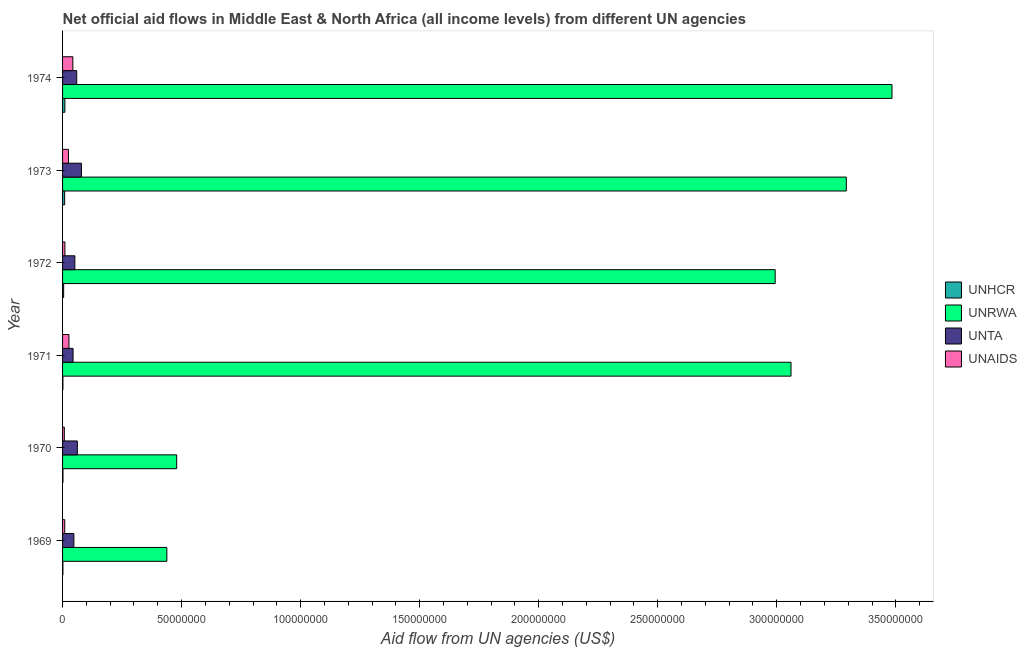Are the number of bars on each tick of the Y-axis equal?
Your response must be concise. Yes. How many bars are there on the 2nd tick from the bottom?
Provide a succinct answer. 4. What is the amount of aid given by unrwa in 1969?
Give a very brief answer. 4.38e+07. Across all years, what is the maximum amount of aid given by unhcr?
Give a very brief answer. 9.70e+05. Across all years, what is the minimum amount of aid given by unaids?
Offer a terse response. 7.40e+05. In which year was the amount of aid given by unrwa maximum?
Make the answer very short. 1974. What is the total amount of aid given by unaids in the graph?
Your answer should be very brief. 1.21e+07. What is the difference between the amount of aid given by unrwa in 1973 and the amount of aid given by unhcr in 1971?
Provide a succinct answer. 3.29e+08. What is the average amount of aid given by unrwa per year?
Offer a very short reply. 2.29e+08. In the year 1969, what is the difference between the amount of aid given by unaids and amount of aid given by unhcr?
Give a very brief answer. 7.70e+05. In how many years, is the amount of aid given by unrwa greater than 10000000 US$?
Make the answer very short. 6. What is the ratio of the amount of aid given by unta in 1969 to that in 1972?
Make the answer very short. 0.92. Is the amount of aid given by unrwa in 1969 less than that in 1971?
Your response must be concise. Yes. What is the difference between the highest and the second highest amount of aid given by unrwa?
Ensure brevity in your answer.  1.92e+07. What is the difference between the highest and the lowest amount of aid given by unhcr?
Your response must be concise. 8.30e+05. In how many years, is the amount of aid given by unrwa greater than the average amount of aid given by unrwa taken over all years?
Ensure brevity in your answer.  4. What does the 3rd bar from the top in 1974 represents?
Provide a succinct answer. UNRWA. What does the 1st bar from the bottom in 1969 represents?
Keep it short and to the point. UNHCR. How many bars are there?
Your answer should be compact. 24. How many years are there in the graph?
Give a very brief answer. 6. Are the values on the major ticks of X-axis written in scientific E-notation?
Ensure brevity in your answer.  No. Does the graph contain grids?
Your answer should be very brief. No. Where does the legend appear in the graph?
Give a very brief answer. Center right. What is the title of the graph?
Give a very brief answer. Net official aid flows in Middle East & North Africa (all income levels) from different UN agencies. What is the label or title of the X-axis?
Your response must be concise. Aid flow from UN agencies (US$). What is the label or title of the Y-axis?
Give a very brief answer. Year. What is the Aid flow from UN agencies (US$) of UNHCR in 1969?
Offer a terse response. 1.40e+05. What is the Aid flow from UN agencies (US$) in UNRWA in 1969?
Your answer should be very brief. 4.38e+07. What is the Aid flow from UN agencies (US$) in UNTA in 1969?
Offer a terse response. 4.75e+06. What is the Aid flow from UN agencies (US$) in UNAIDS in 1969?
Provide a succinct answer. 9.10e+05. What is the Aid flow from UN agencies (US$) in UNHCR in 1970?
Make the answer very short. 1.70e+05. What is the Aid flow from UN agencies (US$) in UNRWA in 1970?
Make the answer very short. 4.79e+07. What is the Aid flow from UN agencies (US$) in UNTA in 1970?
Keep it short and to the point. 6.21e+06. What is the Aid flow from UN agencies (US$) of UNAIDS in 1970?
Your response must be concise. 7.40e+05. What is the Aid flow from UN agencies (US$) of UNHCR in 1971?
Your response must be concise. 1.40e+05. What is the Aid flow from UN agencies (US$) in UNRWA in 1971?
Keep it short and to the point. 3.06e+08. What is the Aid flow from UN agencies (US$) of UNTA in 1971?
Your answer should be compact. 4.41e+06. What is the Aid flow from UN agencies (US$) in UNAIDS in 1971?
Make the answer very short. 2.68e+06. What is the Aid flow from UN agencies (US$) of UNHCR in 1972?
Give a very brief answer. 4.60e+05. What is the Aid flow from UN agencies (US$) in UNRWA in 1972?
Your answer should be very brief. 2.99e+08. What is the Aid flow from UN agencies (US$) in UNTA in 1972?
Your response must be concise. 5.16e+06. What is the Aid flow from UN agencies (US$) of UNAIDS in 1972?
Keep it short and to the point. 9.80e+05. What is the Aid flow from UN agencies (US$) of UNHCR in 1973?
Your answer should be very brief. 8.80e+05. What is the Aid flow from UN agencies (US$) of UNRWA in 1973?
Offer a terse response. 3.29e+08. What is the Aid flow from UN agencies (US$) in UNTA in 1973?
Provide a short and direct response. 7.93e+06. What is the Aid flow from UN agencies (US$) of UNAIDS in 1973?
Your response must be concise. 2.47e+06. What is the Aid flow from UN agencies (US$) in UNHCR in 1974?
Give a very brief answer. 9.70e+05. What is the Aid flow from UN agencies (US$) of UNRWA in 1974?
Offer a terse response. 3.48e+08. What is the Aid flow from UN agencies (US$) of UNTA in 1974?
Your response must be concise. 5.94e+06. What is the Aid flow from UN agencies (US$) in UNAIDS in 1974?
Give a very brief answer. 4.32e+06. Across all years, what is the maximum Aid flow from UN agencies (US$) of UNHCR?
Give a very brief answer. 9.70e+05. Across all years, what is the maximum Aid flow from UN agencies (US$) of UNRWA?
Provide a succinct answer. 3.48e+08. Across all years, what is the maximum Aid flow from UN agencies (US$) in UNTA?
Your answer should be compact. 7.93e+06. Across all years, what is the maximum Aid flow from UN agencies (US$) in UNAIDS?
Make the answer very short. 4.32e+06. Across all years, what is the minimum Aid flow from UN agencies (US$) of UNHCR?
Provide a short and direct response. 1.40e+05. Across all years, what is the minimum Aid flow from UN agencies (US$) of UNRWA?
Provide a short and direct response. 4.38e+07. Across all years, what is the minimum Aid flow from UN agencies (US$) of UNTA?
Keep it short and to the point. 4.41e+06. Across all years, what is the minimum Aid flow from UN agencies (US$) in UNAIDS?
Provide a short and direct response. 7.40e+05. What is the total Aid flow from UN agencies (US$) of UNHCR in the graph?
Provide a short and direct response. 2.76e+06. What is the total Aid flow from UN agencies (US$) in UNRWA in the graph?
Ensure brevity in your answer.  1.37e+09. What is the total Aid flow from UN agencies (US$) of UNTA in the graph?
Your response must be concise. 3.44e+07. What is the total Aid flow from UN agencies (US$) of UNAIDS in the graph?
Make the answer very short. 1.21e+07. What is the difference between the Aid flow from UN agencies (US$) in UNRWA in 1969 and that in 1970?
Offer a terse response. -4.13e+06. What is the difference between the Aid flow from UN agencies (US$) in UNTA in 1969 and that in 1970?
Your response must be concise. -1.46e+06. What is the difference between the Aid flow from UN agencies (US$) in UNAIDS in 1969 and that in 1970?
Provide a succinct answer. 1.70e+05. What is the difference between the Aid flow from UN agencies (US$) of UNRWA in 1969 and that in 1971?
Provide a short and direct response. -2.62e+08. What is the difference between the Aid flow from UN agencies (US$) in UNTA in 1969 and that in 1971?
Give a very brief answer. 3.40e+05. What is the difference between the Aid flow from UN agencies (US$) in UNAIDS in 1969 and that in 1971?
Ensure brevity in your answer.  -1.77e+06. What is the difference between the Aid flow from UN agencies (US$) in UNHCR in 1969 and that in 1972?
Ensure brevity in your answer.  -3.20e+05. What is the difference between the Aid flow from UN agencies (US$) of UNRWA in 1969 and that in 1972?
Ensure brevity in your answer.  -2.56e+08. What is the difference between the Aid flow from UN agencies (US$) in UNTA in 1969 and that in 1972?
Provide a succinct answer. -4.10e+05. What is the difference between the Aid flow from UN agencies (US$) of UNAIDS in 1969 and that in 1972?
Your answer should be compact. -7.00e+04. What is the difference between the Aid flow from UN agencies (US$) in UNHCR in 1969 and that in 1973?
Provide a succinct answer. -7.40e+05. What is the difference between the Aid flow from UN agencies (US$) in UNRWA in 1969 and that in 1973?
Make the answer very short. -2.85e+08. What is the difference between the Aid flow from UN agencies (US$) of UNTA in 1969 and that in 1973?
Your response must be concise. -3.18e+06. What is the difference between the Aid flow from UN agencies (US$) in UNAIDS in 1969 and that in 1973?
Your answer should be very brief. -1.56e+06. What is the difference between the Aid flow from UN agencies (US$) of UNHCR in 1969 and that in 1974?
Offer a very short reply. -8.30e+05. What is the difference between the Aid flow from UN agencies (US$) of UNRWA in 1969 and that in 1974?
Your answer should be compact. -3.05e+08. What is the difference between the Aid flow from UN agencies (US$) in UNTA in 1969 and that in 1974?
Offer a terse response. -1.19e+06. What is the difference between the Aid flow from UN agencies (US$) in UNAIDS in 1969 and that in 1974?
Ensure brevity in your answer.  -3.41e+06. What is the difference between the Aid flow from UN agencies (US$) in UNRWA in 1970 and that in 1971?
Offer a very short reply. -2.58e+08. What is the difference between the Aid flow from UN agencies (US$) in UNTA in 1970 and that in 1971?
Ensure brevity in your answer.  1.80e+06. What is the difference between the Aid flow from UN agencies (US$) of UNAIDS in 1970 and that in 1971?
Give a very brief answer. -1.94e+06. What is the difference between the Aid flow from UN agencies (US$) of UNRWA in 1970 and that in 1972?
Your response must be concise. -2.51e+08. What is the difference between the Aid flow from UN agencies (US$) of UNTA in 1970 and that in 1972?
Ensure brevity in your answer.  1.05e+06. What is the difference between the Aid flow from UN agencies (US$) of UNAIDS in 1970 and that in 1972?
Keep it short and to the point. -2.40e+05. What is the difference between the Aid flow from UN agencies (US$) of UNHCR in 1970 and that in 1973?
Keep it short and to the point. -7.10e+05. What is the difference between the Aid flow from UN agencies (US$) in UNRWA in 1970 and that in 1973?
Your answer should be very brief. -2.81e+08. What is the difference between the Aid flow from UN agencies (US$) of UNTA in 1970 and that in 1973?
Offer a very short reply. -1.72e+06. What is the difference between the Aid flow from UN agencies (US$) in UNAIDS in 1970 and that in 1973?
Ensure brevity in your answer.  -1.73e+06. What is the difference between the Aid flow from UN agencies (US$) in UNHCR in 1970 and that in 1974?
Keep it short and to the point. -8.00e+05. What is the difference between the Aid flow from UN agencies (US$) in UNRWA in 1970 and that in 1974?
Give a very brief answer. -3.00e+08. What is the difference between the Aid flow from UN agencies (US$) of UNAIDS in 1970 and that in 1974?
Provide a short and direct response. -3.58e+06. What is the difference between the Aid flow from UN agencies (US$) in UNHCR in 1971 and that in 1972?
Provide a succinct answer. -3.20e+05. What is the difference between the Aid flow from UN agencies (US$) in UNRWA in 1971 and that in 1972?
Ensure brevity in your answer.  6.65e+06. What is the difference between the Aid flow from UN agencies (US$) of UNTA in 1971 and that in 1972?
Your response must be concise. -7.50e+05. What is the difference between the Aid flow from UN agencies (US$) in UNAIDS in 1971 and that in 1972?
Offer a terse response. 1.70e+06. What is the difference between the Aid flow from UN agencies (US$) in UNHCR in 1971 and that in 1973?
Your response must be concise. -7.40e+05. What is the difference between the Aid flow from UN agencies (US$) in UNRWA in 1971 and that in 1973?
Your answer should be compact. -2.32e+07. What is the difference between the Aid flow from UN agencies (US$) in UNTA in 1971 and that in 1973?
Your answer should be compact. -3.52e+06. What is the difference between the Aid flow from UN agencies (US$) in UNHCR in 1971 and that in 1974?
Your answer should be compact. -8.30e+05. What is the difference between the Aid flow from UN agencies (US$) in UNRWA in 1971 and that in 1974?
Your response must be concise. -4.24e+07. What is the difference between the Aid flow from UN agencies (US$) of UNTA in 1971 and that in 1974?
Make the answer very short. -1.53e+06. What is the difference between the Aid flow from UN agencies (US$) in UNAIDS in 1971 and that in 1974?
Provide a short and direct response. -1.64e+06. What is the difference between the Aid flow from UN agencies (US$) in UNHCR in 1972 and that in 1973?
Offer a terse response. -4.20e+05. What is the difference between the Aid flow from UN agencies (US$) of UNRWA in 1972 and that in 1973?
Provide a succinct answer. -2.99e+07. What is the difference between the Aid flow from UN agencies (US$) in UNTA in 1972 and that in 1973?
Give a very brief answer. -2.77e+06. What is the difference between the Aid flow from UN agencies (US$) of UNAIDS in 1972 and that in 1973?
Offer a very short reply. -1.49e+06. What is the difference between the Aid flow from UN agencies (US$) in UNHCR in 1972 and that in 1974?
Give a very brief answer. -5.10e+05. What is the difference between the Aid flow from UN agencies (US$) in UNRWA in 1972 and that in 1974?
Make the answer very short. -4.91e+07. What is the difference between the Aid flow from UN agencies (US$) in UNTA in 1972 and that in 1974?
Offer a very short reply. -7.80e+05. What is the difference between the Aid flow from UN agencies (US$) in UNAIDS in 1972 and that in 1974?
Offer a very short reply. -3.34e+06. What is the difference between the Aid flow from UN agencies (US$) in UNRWA in 1973 and that in 1974?
Provide a succinct answer. -1.92e+07. What is the difference between the Aid flow from UN agencies (US$) of UNTA in 1973 and that in 1974?
Provide a succinct answer. 1.99e+06. What is the difference between the Aid flow from UN agencies (US$) of UNAIDS in 1973 and that in 1974?
Ensure brevity in your answer.  -1.85e+06. What is the difference between the Aid flow from UN agencies (US$) in UNHCR in 1969 and the Aid flow from UN agencies (US$) in UNRWA in 1970?
Your answer should be compact. -4.78e+07. What is the difference between the Aid flow from UN agencies (US$) of UNHCR in 1969 and the Aid flow from UN agencies (US$) of UNTA in 1970?
Your response must be concise. -6.07e+06. What is the difference between the Aid flow from UN agencies (US$) of UNHCR in 1969 and the Aid flow from UN agencies (US$) of UNAIDS in 1970?
Your response must be concise. -6.00e+05. What is the difference between the Aid flow from UN agencies (US$) of UNRWA in 1969 and the Aid flow from UN agencies (US$) of UNTA in 1970?
Your response must be concise. 3.76e+07. What is the difference between the Aid flow from UN agencies (US$) in UNRWA in 1969 and the Aid flow from UN agencies (US$) in UNAIDS in 1970?
Your answer should be very brief. 4.31e+07. What is the difference between the Aid flow from UN agencies (US$) of UNTA in 1969 and the Aid flow from UN agencies (US$) of UNAIDS in 1970?
Ensure brevity in your answer.  4.01e+06. What is the difference between the Aid flow from UN agencies (US$) of UNHCR in 1969 and the Aid flow from UN agencies (US$) of UNRWA in 1971?
Provide a short and direct response. -3.06e+08. What is the difference between the Aid flow from UN agencies (US$) in UNHCR in 1969 and the Aid flow from UN agencies (US$) in UNTA in 1971?
Offer a very short reply. -4.27e+06. What is the difference between the Aid flow from UN agencies (US$) in UNHCR in 1969 and the Aid flow from UN agencies (US$) in UNAIDS in 1971?
Offer a very short reply. -2.54e+06. What is the difference between the Aid flow from UN agencies (US$) in UNRWA in 1969 and the Aid flow from UN agencies (US$) in UNTA in 1971?
Ensure brevity in your answer.  3.94e+07. What is the difference between the Aid flow from UN agencies (US$) in UNRWA in 1969 and the Aid flow from UN agencies (US$) in UNAIDS in 1971?
Your response must be concise. 4.11e+07. What is the difference between the Aid flow from UN agencies (US$) in UNTA in 1969 and the Aid flow from UN agencies (US$) in UNAIDS in 1971?
Your response must be concise. 2.07e+06. What is the difference between the Aid flow from UN agencies (US$) in UNHCR in 1969 and the Aid flow from UN agencies (US$) in UNRWA in 1972?
Your answer should be very brief. -2.99e+08. What is the difference between the Aid flow from UN agencies (US$) in UNHCR in 1969 and the Aid flow from UN agencies (US$) in UNTA in 1972?
Keep it short and to the point. -5.02e+06. What is the difference between the Aid flow from UN agencies (US$) in UNHCR in 1969 and the Aid flow from UN agencies (US$) in UNAIDS in 1972?
Keep it short and to the point. -8.40e+05. What is the difference between the Aid flow from UN agencies (US$) of UNRWA in 1969 and the Aid flow from UN agencies (US$) of UNTA in 1972?
Provide a short and direct response. 3.86e+07. What is the difference between the Aid flow from UN agencies (US$) in UNRWA in 1969 and the Aid flow from UN agencies (US$) in UNAIDS in 1972?
Ensure brevity in your answer.  4.28e+07. What is the difference between the Aid flow from UN agencies (US$) of UNTA in 1969 and the Aid flow from UN agencies (US$) of UNAIDS in 1972?
Make the answer very short. 3.77e+06. What is the difference between the Aid flow from UN agencies (US$) in UNHCR in 1969 and the Aid flow from UN agencies (US$) in UNRWA in 1973?
Your response must be concise. -3.29e+08. What is the difference between the Aid flow from UN agencies (US$) in UNHCR in 1969 and the Aid flow from UN agencies (US$) in UNTA in 1973?
Make the answer very short. -7.79e+06. What is the difference between the Aid flow from UN agencies (US$) in UNHCR in 1969 and the Aid flow from UN agencies (US$) in UNAIDS in 1973?
Ensure brevity in your answer.  -2.33e+06. What is the difference between the Aid flow from UN agencies (US$) of UNRWA in 1969 and the Aid flow from UN agencies (US$) of UNTA in 1973?
Your response must be concise. 3.59e+07. What is the difference between the Aid flow from UN agencies (US$) of UNRWA in 1969 and the Aid flow from UN agencies (US$) of UNAIDS in 1973?
Make the answer very short. 4.13e+07. What is the difference between the Aid flow from UN agencies (US$) in UNTA in 1969 and the Aid flow from UN agencies (US$) in UNAIDS in 1973?
Ensure brevity in your answer.  2.28e+06. What is the difference between the Aid flow from UN agencies (US$) of UNHCR in 1969 and the Aid flow from UN agencies (US$) of UNRWA in 1974?
Give a very brief answer. -3.48e+08. What is the difference between the Aid flow from UN agencies (US$) of UNHCR in 1969 and the Aid flow from UN agencies (US$) of UNTA in 1974?
Ensure brevity in your answer.  -5.80e+06. What is the difference between the Aid flow from UN agencies (US$) of UNHCR in 1969 and the Aid flow from UN agencies (US$) of UNAIDS in 1974?
Offer a terse response. -4.18e+06. What is the difference between the Aid flow from UN agencies (US$) of UNRWA in 1969 and the Aid flow from UN agencies (US$) of UNTA in 1974?
Ensure brevity in your answer.  3.79e+07. What is the difference between the Aid flow from UN agencies (US$) of UNRWA in 1969 and the Aid flow from UN agencies (US$) of UNAIDS in 1974?
Ensure brevity in your answer.  3.95e+07. What is the difference between the Aid flow from UN agencies (US$) of UNHCR in 1970 and the Aid flow from UN agencies (US$) of UNRWA in 1971?
Ensure brevity in your answer.  -3.06e+08. What is the difference between the Aid flow from UN agencies (US$) in UNHCR in 1970 and the Aid flow from UN agencies (US$) in UNTA in 1971?
Make the answer very short. -4.24e+06. What is the difference between the Aid flow from UN agencies (US$) in UNHCR in 1970 and the Aid flow from UN agencies (US$) in UNAIDS in 1971?
Your answer should be compact. -2.51e+06. What is the difference between the Aid flow from UN agencies (US$) of UNRWA in 1970 and the Aid flow from UN agencies (US$) of UNTA in 1971?
Give a very brief answer. 4.35e+07. What is the difference between the Aid flow from UN agencies (US$) in UNRWA in 1970 and the Aid flow from UN agencies (US$) in UNAIDS in 1971?
Provide a short and direct response. 4.52e+07. What is the difference between the Aid flow from UN agencies (US$) in UNTA in 1970 and the Aid flow from UN agencies (US$) in UNAIDS in 1971?
Your answer should be very brief. 3.53e+06. What is the difference between the Aid flow from UN agencies (US$) in UNHCR in 1970 and the Aid flow from UN agencies (US$) in UNRWA in 1972?
Give a very brief answer. -2.99e+08. What is the difference between the Aid flow from UN agencies (US$) in UNHCR in 1970 and the Aid flow from UN agencies (US$) in UNTA in 1972?
Offer a terse response. -4.99e+06. What is the difference between the Aid flow from UN agencies (US$) in UNHCR in 1970 and the Aid flow from UN agencies (US$) in UNAIDS in 1972?
Your answer should be compact. -8.10e+05. What is the difference between the Aid flow from UN agencies (US$) in UNRWA in 1970 and the Aid flow from UN agencies (US$) in UNTA in 1972?
Your response must be concise. 4.28e+07. What is the difference between the Aid flow from UN agencies (US$) in UNRWA in 1970 and the Aid flow from UN agencies (US$) in UNAIDS in 1972?
Make the answer very short. 4.70e+07. What is the difference between the Aid flow from UN agencies (US$) in UNTA in 1970 and the Aid flow from UN agencies (US$) in UNAIDS in 1972?
Give a very brief answer. 5.23e+06. What is the difference between the Aid flow from UN agencies (US$) of UNHCR in 1970 and the Aid flow from UN agencies (US$) of UNRWA in 1973?
Your answer should be very brief. -3.29e+08. What is the difference between the Aid flow from UN agencies (US$) of UNHCR in 1970 and the Aid flow from UN agencies (US$) of UNTA in 1973?
Provide a short and direct response. -7.76e+06. What is the difference between the Aid flow from UN agencies (US$) in UNHCR in 1970 and the Aid flow from UN agencies (US$) in UNAIDS in 1973?
Ensure brevity in your answer.  -2.30e+06. What is the difference between the Aid flow from UN agencies (US$) in UNRWA in 1970 and the Aid flow from UN agencies (US$) in UNTA in 1973?
Ensure brevity in your answer.  4.00e+07. What is the difference between the Aid flow from UN agencies (US$) in UNRWA in 1970 and the Aid flow from UN agencies (US$) in UNAIDS in 1973?
Provide a succinct answer. 4.55e+07. What is the difference between the Aid flow from UN agencies (US$) in UNTA in 1970 and the Aid flow from UN agencies (US$) in UNAIDS in 1973?
Give a very brief answer. 3.74e+06. What is the difference between the Aid flow from UN agencies (US$) of UNHCR in 1970 and the Aid flow from UN agencies (US$) of UNRWA in 1974?
Offer a terse response. -3.48e+08. What is the difference between the Aid flow from UN agencies (US$) in UNHCR in 1970 and the Aid flow from UN agencies (US$) in UNTA in 1974?
Offer a terse response. -5.77e+06. What is the difference between the Aid flow from UN agencies (US$) in UNHCR in 1970 and the Aid flow from UN agencies (US$) in UNAIDS in 1974?
Your response must be concise. -4.15e+06. What is the difference between the Aid flow from UN agencies (US$) in UNRWA in 1970 and the Aid flow from UN agencies (US$) in UNTA in 1974?
Provide a succinct answer. 4.20e+07. What is the difference between the Aid flow from UN agencies (US$) of UNRWA in 1970 and the Aid flow from UN agencies (US$) of UNAIDS in 1974?
Keep it short and to the point. 4.36e+07. What is the difference between the Aid flow from UN agencies (US$) of UNTA in 1970 and the Aid flow from UN agencies (US$) of UNAIDS in 1974?
Give a very brief answer. 1.89e+06. What is the difference between the Aid flow from UN agencies (US$) in UNHCR in 1971 and the Aid flow from UN agencies (US$) in UNRWA in 1972?
Ensure brevity in your answer.  -2.99e+08. What is the difference between the Aid flow from UN agencies (US$) in UNHCR in 1971 and the Aid flow from UN agencies (US$) in UNTA in 1972?
Make the answer very short. -5.02e+06. What is the difference between the Aid flow from UN agencies (US$) of UNHCR in 1971 and the Aid flow from UN agencies (US$) of UNAIDS in 1972?
Your answer should be compact. -8.40e+05. What is the difference between the Aid flow from UN agencies (US$) in UNRWA in 1971 and the Aid flow from UN agencies (US$) in UNTA in 1972?
Your answer should be compact. 3.01e+08. What is the difference between the Aid flow from UN agencies (US$) in UNRWA in 1971 and the Aid flow from UN agencies (US$) in UNAIDS in 1972?
Your answer should be compact. 3.05e+08. What is the difference between the Aid flow from UN agencies (US$) in UNTA in 1971 and the Aid flow from UN agencies (US$) in UNAIDS in 1972?
Keep it short and to the point. 3.43e+06. What is the difference between the Aid flow from UN agencies (US$) in UNHCR in 1971 and the Aid flow from UN agencies (US$) in UNRWA in 1973?
Make the answer very short. -3.29e+08. What is the difference between the Aid flow from UN agencies (US$) in UNHCR in 1971 and the Aid flow from UN agencies (US$) in UNTA in 1973?
Your response must be concise. -7.79e+06. What is the difference between the Aid flow from UN agencies (US$) of UNHCR in 1971 and the Aid flow from UN agencies (US$) of UNAIDS in 1973?
Your response must be concise. -2.33e+06. What is the difference between the Aid flow from UN agencies (US$) in UNRWA in 1971 and the Aid flow from UN agencies (US$) in UNTA in 1973?
Offer a terse response. 2.98e+08. What is the difference between the Aid flow from UN agencies (US$) of UNRWA in 1971 and the Aid flow from UN agencies (US$) of UNAIDS in 1973?
Your answer should be very brief. 3.04e+08. What is the difference between the Aid flow from UN agencies (US$) of UNTA in 1971 and the Aid flow from UN agencies (US$) of UNAIDS in 1973?
Your answer should be compact. 1.94e+06. What is the difference between the Aid flow from UN agencies (US$) of UNHCR in 1971 and the Aid flow from UN agencies (US$) of UNRWA in 1974?
Ensure brevity in your answer.  -3.48e+08. What is the difference between the Aid flow from UN agencies (US$) in UNHCR in 1971 and the Aid flow from UN agencies (US$) in UNTA in 1974?
Ensure brevity in your answer.  -5.80e+06. What is the difference between the Aid flow from UN agencies (US$) of UNHCR in 1971 and the Aid flow from UN agencies (US$) of UNAIDS in 1974?
Offer a very short reply. -4.18e+06. What is the difference between the Aid flow from UN agencies (US$) of UNRWA in 1971 and the Aid flow from UN agencies (US$) of UNTA in 1974?
Keep it short and to the point. 3.00e+08. What is the difference between the Aid flow from UN agencies (US$) in UNRWA in 1971 and the Aid flow from UN agencies (US$) in UNAIDS in 1974?
Offer a terse response. 3.02e+08. What is the difference between the Aid flow from UN agencies (US$) of UNHCR in 1972 and the Aid flow from UN agencies (US$) of UNRWA in 1973?
Your answer should be compact. -3.29e+08. What is the difference between the Aid flow from UN agencies (US$) of UNHCR in 1972 and the Aid flow from UN agencies (US$) of UNTA in 1973?
Keep it short and to the point. -7.47e+06. What is the difference between the Aid flow from UN agencies (US$) in UNHCR in 1972 and the Aid flow from UN agencies (US$) in UNAIDS in 1973?
Ensure brevity in your answer.  -2.01e+06. What is the difference between the Aid flow from UN agencies (US$) of UNRWA in 1972 and the Aid flow from UN agencies (US$) of UNTA in 1973?
Offer a terse response. 2.91e+08. What is the difference between the Aid flow from UN agencies (US$) of UNRWA in 1972 and the Aid flow from UN agencies (US$) of UNAIDS in 1973?
Your answer should be compact. 2.97e+08. What is the difference between the Aid flow from UN agencies (US$) in UNTA in 1972 and the Aid flow from UN agencies (US$) in UNAIDS in 1973?
Your response must be concise. 2.69e+06. What is the difference between the Aid flow from UN agencies (US$) in UNHCR in 1972 and the Aid flow from UN agencies (US$) in UNRWA in 1974?
Offer a very short reply. -3.48e+08. What is the difference between the Aid flow from UN agencies (US$) of UNHCR in 1972 and the Aid flow from UN agencies (US$) of UNTA in 1974?
Keep it short and to the point. -5.48e+06. What is the difference between the Aid flow from UN agencies (US$) of UNHCR in 1972 and the Aid flow from UN agencies (US$) of UNAIDS in 1974?
Your answer should be compact. -3.86e+06. What is the difference between the Aid flow from UN agencies (US$) of UNRWA in 1972 and the Aid flow from UN agencies (US$) of UNTA in 1974?
Offer a terse response. 2.93e+08. What is the difference between the Aid flow from UN agencies (US$) of UNRWA in 1972 and the Aid flow from UN agencies (US$) of UNAIDS in 1974?
Keep it short and to the point. 2.95e+08. What is the difference between the Aid flow from UN agencies (US$) in UNTA in 1972 and the Aid flow from UN agencies (US$) in UNAIDS in 1974?
Provide a short and direct response. 8.40e+05. What is the difference between the Aid flow from UN agencies (US$) in UNHCR in 1973 and the Aid flow from UN agencies (US$) in UNRWA in 1974?
Keep it short and to the point. -3.48e+08. What is the difference between the Aid flow from UN agencies (US$) in UNHCR in 1973 and the Aid flow from UN agencies (US$) in UNTA in 1974?
Your answer should be very brief. -5.06e+06. What is the difference between the Aid flow from UN agencies (US$) in UNHCR in 1973 and the Aid flow from UN agencies (US$) in UNAIDS in 1974?
Provide a succinct answer. -3.44e+06. What is the difference between the Aid flow from UN agencies (US$) in UNRWA in 1973 and the Aid flow from UN agencies (US$) in UNTA in 1974?
Provide a succinct answer. 3.23e+08. What is the difference between the Aid flow from UN agencies (US$) in UNRWA in 1973 and the Aid flow from UN agencies (US$) in UNAIDS in 1974?
Give a very brief answer. 3.25e+08. What is the difference between the Aid flow from UN agencies (US$) of UNTA in 1973 and the Aid flow from UN agencies (US$) of UNAIDS in 1974?
Offer a terse response. 3.61e+06. What is the average Aid flow from UN agencies (US$) of UNRWA per year?
Make the answer very short. 2.29e+08. What is the average Aid flow from UN agencies (US$) of UNTA per year?
Your response must be concise. 5.73e+06. What is the average Aid flow from UN agencies (US$) of UNAIDS per year?
Provide a short and direct response. 2.02e+06. In the year 1969, what is the difference between the Aid flow from UN agencies (US$) in UNHCR and Aid flow from UN agencies (US$) in UNRWA?
Offer a terse response. -4.37e+07. In the year 1969, what is the difference between the Aid flow from UN agencies (US$) in UNHCR and Aid flow from UN agencies (US$) in UNTA?
Ensure brevity in your answer.  -4.61e+06. In the year 1969, what is the difference between the Aid flow from UN agencies (US$) of UNHCR and Aid flow from UN agencies (US$) of UNAIDS?
Your response must be concise. -7.70e+05. In the year 1969, what is the difference between the Aid flow from UN agencies (US$) in UNRWA and Aid flow from UN agencies (US$) in UNTA?
Ensure brevity in your answer.  3.90e+07. In the year 1969, what is the difference between the Aid flow from UN agencies (US$) of UNRWA and Aid flow from UN agencies (US$) of UNAIDS?
Your answer should be compact. 4.29e+07. In the year 1969, what is the difference between the Aid flow from UN agencies (US$) in UNTA and Aid flow from UN agencies (US$) in UNAIDS?
Offer a terse response. 3.84e+06. In the year 1970, what is the difference between the Aid flow from UN agencies (US$) of UNHCR and Aid flow from UN agencies (US$) of UNRWA?
Your response must be concise. -4.78e+07. In the year 1970, what is the difference between the Aid flow from UN agencies (US$) of UNHCR and Aid flow from UN agencies (US$) of UNTA?
Provide a succinct answer. -6.04e+06. In the year 1970, what is the difference between the Aid flow from UN agencies (US$) in UNHCR and Aid flow from UN agencies (US$) in UNAIDS?
Provide a short and direct response. -5.70e+05. In the year 1970, what is the difference between the Aid flow from UN agencies (US$) in UNRWA and Aid flow from UN agencies (US$) in UNTA?
Ensure brevity in your answer.  4.17e+07. In the year 1970, what is the difference between the Aid flow from UN agencies (US$) in UNRWA and Aid flow from UN agencies (US$) in UNAIDS?
Your response must be concise. 4.72e+07. In the year 1970, what is the difference between the Aid flow from UN agencies (US$) in UNTA and Aid flow from UN agencies (US$) in UNAIDS?
Provide a succinct answer. 5.47e+06. In the year 1971, what is the difference between the Aid flow from UN agencies (US$) of UNHCR and Aid flow from UN agencies (US$) of UNRWA?
Make the answer very short. -3.06e+08. In the year 1971, what is the difference between the Aid flow from UN agencies (US$) in UNHCR and Aid flow from UN agencies (US$) in UNTA?
Your answer should be compact. -4.27e+06. In the year 1971, what is the difference between the Aid flow from UN agencies (US$) in UNHCR and Aid flow from UN agencies (US$) in UNAIDS?
Provide a short and direct response. -2.54e+06. In the year 1971, what is the difference between the Aid flow from UN agencies (US$) in UNRWA and Aid flow from UN agencies (US$) in UNTA?
Offer a very short reply. 3.02e+08. In the year 1971, what is the difference between the Aid flow from UN agencies (US$) of UNRWA and Aid flow from UN agencies (US$) of UNAIDS?
Keep it short and to the point. 3.03e+08. In the year 1971, what is the difference between the Aid flow from UN agencies (US$) of UNTA and Aid flow from UN agencies (US$) of UNAIDS?
Your response must be concise. 1.73e+06. In the year 1972, what is the difference between the Aid flow from UN agencies (US$) in UNHCR and Aid flow from UN agencies (US$) in UNRWA?
Ensure brevity in your answer.  -2.99e+08. In the year 1972, what is the difference between the Aid flow from UN agencies (US$) in UNHCR and Aid flow from UN agencies (US$) in UNTA?
Keep it short and to the point. -4.70e+06. In the year 1972, what is the difference between the Aid flow from UN agencies (US$) in UNHCR and Aid flow from UN agencies (US$) in UNAIDS?
Your response must be concise. -5.20e+05. In the year 1972, what is the difference between the Aid flow from UN agencies (US$) of UNRWA and Aid flow from UN agencies (US$) of UNTA?
Give a very brief answer. 2.94e+08. In the year 1972, what is the difference between the Aid flow from UN agencies (US$) of UNRWA and Aid flow from UN agencies (US$) of UNAIDS?
Provide a succinct answer. 2.98e+08. In the year 1972, what is the difference between the Aid flow from UN agencies (US$) of UNTA and Aid flow from UN agencies (US$) of UNAIDS?
Your answer should be very brief. 4.18e+06. In the year 1973, what is the difference between the Aid flow from UN agencies (US$) in UNHCR and Aid flow from UN agencies (US$) in UNRWA?
Make the answer very short. -3.28e+08. In the year 1973, what is the difference between the Aid flow from UN agencies (US$) in UNHCR and Aid flow from UN agencies (US$) in UNTA?
Offer a very short reply. -7.05e+06. In the year 1973, what is the difference between the Aid flow from UN agencies (US$) in UNHCR and Aid flow from UN agencies (US$) in UNAIDS?
Provide a succinct answer. -1.59e+06. In the year 1973, what is the difference between the Aid flow from UN agencies (US$) in UNRWA and Aid flow from UN agencies (US$) in UNTA?
Provide a short and direct response. 3.21e+08. In the year 1973, what is the difference between the Aid flow from UN agencies (US$) in UNRWA and Aid flow from UN agencies (US$) in UNAIDS?
Keep it short and to the point. 3.27e+08. In the year 1973, what is the difference between the Aid flow from UN agencies (US$) in UNTA and Aid flow from UN agencies (US$) in UNAIDS?
Provide a short and direct response. 5.46e+06. In the year 1974, what is the difference between the Aid flow from UN agencies (US$) in UNHCR and Aid flow from UN agencies (US$) in UNRWA?
Provide a short and direct response. -3.47e+08. In the year 1974, what is the difference between the Aid flow from UN agencies (US$) in UNHCR and Aid flow from UN agencies (US$) in UNTA?
Your answer should be compact. -4.97e+06. In the year 1974, what is the difference between the Aid flow from UN agencies (US$) in UNHCR and Aid flow from UN agencies (US$) in UNAIDS?
Provide a succinct answer. -3.35e+06. In the year 1974, what is the difference between the Aid flow from UN agencies (US$) of UNRWA and Aid flow from UN agencies (US$) of UNTA?
Make the answer very short. 3.42e+08. In the year 1974, what is the difference between the Aid flow from UN agencies (US$) in UNRWA and Aid flow from UN agencies (US$) in UNAIDS?
Keep it short and to the point. 3.44e+08. In the year 1974, what is the difference between the Aid flow from UN agencies (US$) in UNTA and Aid flow from UN agencies (US$) in UNAIDS?
Ensure brevity in your answer.  1.62e+06. What is the ratio of the Aid flow from UN agencies (US$) in UNHCR in 1969 to that in 1970?
Your answer should be compact. 0.82. What is the ratio of the Aid flow from UN agencies (US$) in UNRWA in 1969 to that in 1970?
Provide a succinct answer. 0.91. What is the ratio of the Aid flow from UN agencies (US$) of UNTA in 1969 to that in 1970?
Keep it short and to the point. 0.76. What is the ratio of the Aid flow from UN agencies (US$) of UNAIDS in 1969 to that in 1970?
Offer a very short reply. 1.23. What is the ratio of the Aid flow from UN agencies (US$) in UNRWA in 1969 to that in 1971?
Your answer should be very brief. 0.14. What is the ratio of the Aid flow from UN agencies (US$) in UNTA in 1969 to that in 1971?
Give a very brief answer. 1.08. What is the ratio of the Aid flow from UN agencies (US$) of UNAIDS in 1969 to that in 1971?
Keep it short and to the point. 0.34. What is the ratio of the Aid flow from UN agencies (US$) of UNHCR in 1969 to that in 1972?
Your response must be concise. 0.3. What is the ratio of the Aid flow from UN agencies (US$) of UNRWA in 1969 to that in 1972?
Provide a short and direct response. 0.15. What is the ratio of the Aid flow from UN agencies (US$) of UNTA in 1969 to that in 1972?
Your answer should be compact. 0.92. What is the ratio of the Aid flow from UN agencies (US$) of UNHCR in 1969 to that in 1973?
Give a very brief answer. 0.16. What is the ratio of the Aid flow from UN agencies (US$) of UNRWA in 1969 to that in 1973?
Offer a very short reply. 0.13. What is the ratio of the Aid flow from UN agencies (US$) of UNTA in 1969 to that in 1973?
Offer a terse response. 0.6. What is the ratio of the Aid flow from UN agencies (US$) in UNAIDS in 1969 to that in 1973?
Offer a very short reply. 0.37. What is the ratio of the Aid flow from UN agencies (US$) in UNHCR in 1969 to that in 1974?
Your answer should be very brief. 0.14. What is the ratio of the Aid flow from UN agencies (US$) in UNRWA in 1969 to that in 1974?
Your answer should be very brief. 0.13. What is the ratio of the Aid flow from UN agencies (US$) in UNTA in 1969 to that in 1974?
Ensure brevity in your answer.  0.8. What is the ratio of the Aid flow from UN agencies (US$) in UNAIDS in 1969 to that in 1974?
Ensure brevity in your answer.  0.21. What is the ratio of the Aid flow from UN agencies (US$) in UNHCR in 1970 to that in 1971?
Provide a succinct answer. 1.21. What is the ratio of the Aid flow from UN agencies (US$) in UNRWA in 1970 to that in 1971?
Your response must be concise. 0.16. What is the ratio of the Aid flow from UN agencies (US$) of UNTA in 1970 to that in 1971?
Provide a short and direct response. 1.41. What is the ratio of the Aid flow from UN agencies (US$) of UNAIDS in 1970 to that in 1971?
Your answer should be compact. 0.28. What is the ratio of the Aid flow from UN agencies (US$) in UNHCR in 1970 to that in 1972?
Give a very brief answer. 0.37. What is the ratio of the Aid flow from UN agencies (US$) of UNRWA in 1970 to that in 1972?
Your answer should be very brief. 0.16. What is the ratio of the Aid flow from UN agencies (US$) of UNTA in 1970 to that in 1972?
Your answer should be very brief. 1.2. What is the ratio of the Aid flow from UN agencies (US$) of UNAIDS in 1970 to that in 1972?
Provide a short and direct response. 0.76. What is the ratio of the Aid flow from UN agencies (US$) of UNHCR in 1970 to that in 1973?
Your response must be concise. 0.19. What is the ratio of the Aid flow from UN agencies (US$) in UNRWA in 1970 to that in 1973?
Offer a terse response. 0.15. What is the ratio of the Aid flow from UN agencies (US$) in UNTA in 1970 to that in 1973?
Keep it short and to the point. 0.78. What is the ratio of the Aid flow from UN agencies (US$) of UNAIDS in 1970 to that in 1973?
Keep it short and to the point. 0.3. What is the ratio of the Aid flow from UN agencies (US$) in UNHCR in 1970 to that in 1974?
Offer a terse response. 0.18. What is the ratio of the Aid flow from UN agencies (US$) in UNRWA in 1970 to that in 1974?
Give a very brief answer. 0.14. What is the ratio of the Aid flow from UN agencies (US$) of UNTA in 1970 to that in 1974?
Offer a terse response. 1.05. What is the ratio of the Aid flow from UN agencies (US$) of UNAIDS in 1970 to that in 1974?
Make the answer very short. 0.17. What is the ratio of the Aid flow from UN agencies (US$) of UNHCR in 1971 to that in 1972?
Give a very brief answer. 0.3. What is the ratio of the Aid flow from UN agencies (US$) in UNRWA in 1971 to that in 1972?
Make the answer very short. 1.02. What is the ratio of the Aid flow from UN agencies (US$) in UNTA in 1971 to that in 1972?
Your response must be concise. 0.85. What is the ratio of the Aid flow from UN agencies (US$) of UNAIDS in 1971 to that in 1972?
Give a very brief answer. 2.73. What is the ratio of the Aid flow from UN agencies (US$) of UNHCR in 1971 to that in 1973?
Give a very brief answer. 0.16. What is the ratio of the Aid flow from UN agencies (US$) of UNRWA in 1971 to that in 1973?
Your answer should be very brief. 0.93. What is the ratio of the Aid flow from UN agencies (US$) in UNTA in 1971 to that in 1973?
Ensure brevity in your answer.  0.56. What is the ratio of the Aid flow from UN agencies (US$) of UNAIDS in 1971 to that in 1973?
Give a very brief answer. 1.08. What is the ratio of the Aid flow from UN agencies (US$) of UNHCR in 1971 to that in 1974?
Your answer should be very brief. 0.14. What is the ratio of the Aid flow from UN agencies (US$) of UNRWA in 1971 to that in 1974?
Give a very brief answer. 0.88. What is the ratio of the Aid flow from UN agencies (US$) in UNTA in 1971 to that in 1974?
Provide a short and direct response. 0.74. What is the ratio of the Aid flow from UN agencies (US$) of UNAIDS in 1971 to that in 1974?
Keep it short and to the point. 0.62. What is the ratio of the Aid flow from UN agencies (US$) in UNHCR in 1972 to that in 1973?
Ensure brevity in your answer.  0.52. What is the ratio of the Aid flow from UN agencies (US$) in UNRWA in 1972 to that in 1973?
Give a very brief answer. 0.91. What is the ratio of the Aid flow from UN agencies (US$) in UNTA in 1972 to that in 1973?
Ensure brevity in your answer.  0.65. What is the ratio of the Aid flow from UN agencies (US$) of UNAIDS in 1972 to that in 1973?
Offer a very short reply. 0.4. What is the ratio of the Aid flow from UN agencies (US$) of UNHCR in 1972 to that in 1974?
Give a very brief answer. 0.47. What is the ratio of the Aid flow from UN agencies (US$) in UNRWA in 1972 to that in 1974?
Your answer should be very brief. 0.86. What is the ratio of the Aid flow from UN agencies (US$) of UNTA in 1972 to that in 1974?
Your answer should be compact. 0.87. What is the ratio of the Aid flow from UN agencies (US$) in UNAIDS in 1972 to that in 1974?
Your response must be concise. 0.23. What is the ratio of the Aid flow from UN agencies (US$) of UNHCR in 1973 to that in 1974?
Your answer should be compact. 0.91. What is the ratio of the Aid flow from UN agencies (US$) of UNRWA in 1973 to that in 1974?
Your answer should be very brief. 0.94. What is the ratio of the Aid flow from UN agencies (US$) in UNTA in 1973 to that in 1974?
Give a very brief answer. 1.33. What is the ratio of the Aid flow from UN agencies (US$) in UNAIDS in 1973 to that in 1974?
Your answer should be very brief. 0.57. What is the difference between the highest and the second highest Aid flow from UN agencies (US$) in UNRWA?
Provide a short and direct response. 1.92e+07. What is the difference between the highest and the second highest Aid flow from UN agencies (US$) of UNTA?
Your response must be concise. 1.72e+06. What is the difference between the highest and the second highest Aid flow from UN agencies (US$) in UNAIDS?
Keep it short and to the point. 1.64e+06. What is the difference between the highest and the lowest Aid flow from UN agencies (US$) in UNHCR?
Make the answer very short. 8.30e+05. What is the difference between the highest and the lowest Aid flow from UN agencies (US$) in UNRWA?
Your answer should be compact. 3.05e+08. What is the difference between the highest and the lowest Aid flow from UN agencies (US$) in UNTA?
Make the answer very short. 3.52e+06. What is the difference between the highest and the lowest Aid flow from UN agencies (US$) of UNAIDS?
Offer a very short reply. 3.58e+06. 